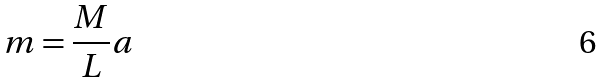Convert formula to latex. <formula><loc_0><loc_0><loc_500><loc_500>m = \frac { M } { L } a</formula> 